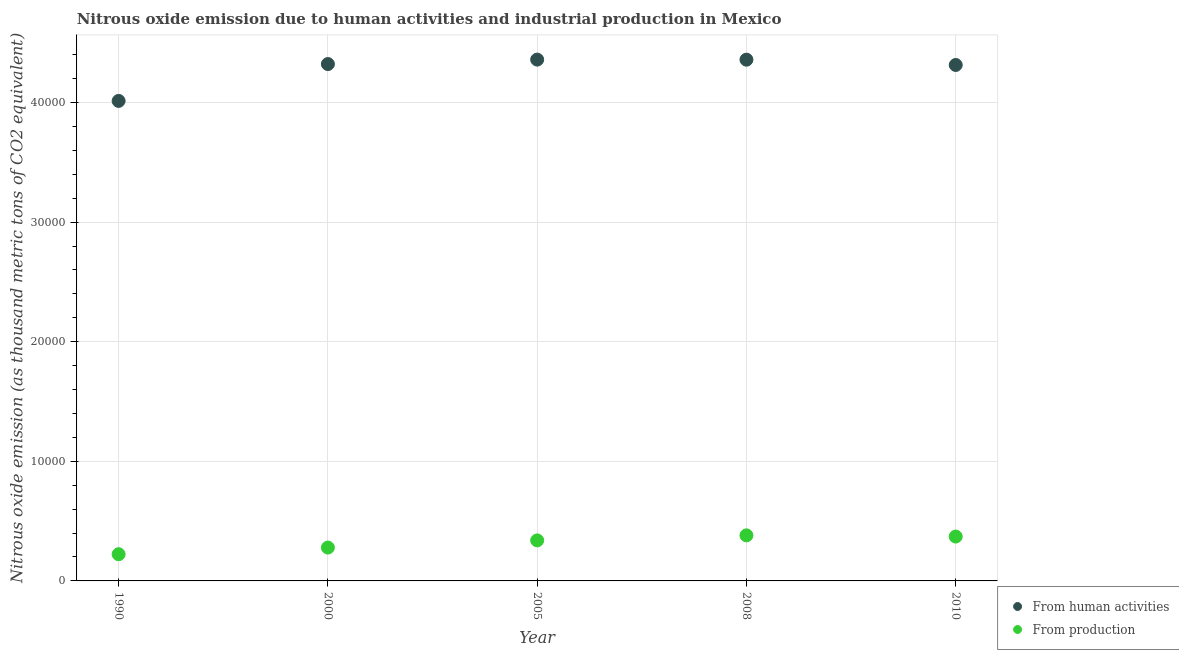What is the amount of emissions generated from industries in 2005?
Give a very brief answer. 3387.8. Across all years, what is the maximum amount of emissions from human activities?
Your answer should be very brief. 4.36e+04. Across all years, what is the minimum amount of emissions from human activities?
Offer a terse response. 4.01e+04. In which year was the amount of emissions generated from industries maximum?
Provide a succinct answer. 2008. What is the total amount of emissions from human activities in the graph?
Offer a very short reply. 2.14e+05. What is the difference between the amount of emissions from human activities in 2000 and that in 2010?
Offer a very short reply. 76.4. What is the difference between the amount of emissions from human activities in 2000 and the amount of emissions generated from industries in 2005?
Make the answer very short. 3.98e+04. What is the average amount of emissions from human activities per year?
Give a very brief answer. 4.27e+04. In the year 2000, what is the difference between the amount of emissions from human activities and amount of emissions generated from industries?
Ensure brevity in your answer.  4.04e+04. What is the ratio of the amount of emissions from human activities in 2000 to that in 2008?
Keep it short and to the point. 0.99. Is the amount of emissions from human activities in 2000 less than that in 2005?
Provide a succinct answer. Yes. Is the difference between the amount of emissions generated from industries in 2005 and 2008 greater than the difference between the amount of emissions from human activities in 2005 and 2008?
Offer a terse response. No. What is the difference between the highest and the second highest amount of emissions generated from industries?
Make the answer very short. 99.5. What is the difference between the highest and the lowest amount of emissions from human activities?
Your answer should be very brief. 3453. In how many years, is the amount of emissions generated from industries greater than the average amount of emissions generated from industries taken over all years?
Make the answer very short. 3. Is the sum of the amount of emissions from human activities in 1990 and 2010 greater than the maximum amount of emissions generated from industries across all years?
Offer a terse response. Yes. Does the amount of emissions from human activities monotonically increase over the years?
Keep it short and to the point. No. Is the amount of emissions from human activities strictly less than the amount of emissions generated from industries over the years?
Offer a terse response. No. Are the values on the major ticks of Y-axis written in scientific E-notation?
Offer a terse response. No. Does the graph contain grids?
Provide a succinct answer. Yes. Where does the legend appear in the graph?
Provide a succinct answer. Bottom right. How are the legend labels stacked?
Ensure brevity in your answer.  Vertical. What is the title of the graph?
Provide a short and direct response. Nitrous oxide emission due to human activities and industrial production in Mexico. What is the label or title of the X-axis?
Your response must be concise. Year. What is the label or title of the Y-axis?
Ensure brevity in your answer.  Nitrous oxide emission (as thousand metric tons of CO2 equivalent). What is the Nitrous oxide emission (as thousand metric tons of CO2 equivalent) of From human activities in 1990?
Keep it short and to the point. 4.01e+04. What is the Nitrous oxide emission (as thousand metric tons of CO2 equivalent) in From production in 1990?
Make the answer very short. 2233.4. What is the Nitrous oxide emission (as thousand metric tons of CO2 equivalent) in From human activities in 2000?
Offer a terse response. 4.32e+04. What is the Nitrous oxide emission (as thousand metric tons of CO2 equivalent) of From production in 2000?
Provide a short and direct response. 2789.1. What is the Nitrous oxide emission (as thousand metric tons of CO2 equivalent) in From human activities in 2005?
Give a very brief answer. 4.36e+04. What is the Nitrous oxide emission (as thousand metric tons of CO2 equivalent) in From production in 2005?
Your response must be concise. 3387.8. What is the Nitrous oxide emission (as thousand metric tons of CO2 equivalent) of From human activities in 2008?
Your response must be concise. 4.36e+04. What is the Nitrous oxide emission (as thousand metric tons of CO2 equivalent) in From production in 2008?
Offer a terse response. 3808.7. What is the Nitrous oxide emission (as thousand metric tons of CO2 equivalent) of From human activities in 2010?
Provide a short and direct response. 4.31e+04. What is the Nitrous oxide emission (as thousand metric tons of CO2 equivalent) in From production in 2010?
Your answer should be compact. 3709.2. Across all years, what is the maximum Nitrous oxide emission (as thousand metric tons of CO2 equivalent) in From human activities?
Make the answer very short. 4.36e+04. Across all years, what is the maximum Nitrous oxide emission (as thousand metric tons of CO2 equivalent) of From production?
Give a very brief answer. 3808.7. Across all years, what is the minimum Nitrous oxide emission (as thousand metric tons of CO2 equivalent) in From human activities?
Give a very brief answer. 4.01e+04. Across all years, what is the minimum Nitrous oxide emission (as thousand metric tons of CO2 equivalent) of From production?
Give a very brief answer. 2233.4. What is the total Nitrous oxide emission (as thousand metric tons of CO2 equivalent) of From human activities in the graph?
Your response must be concise. 2.14e+05. What is the total Nitrous oxide emission (as thousand metric tons of CO2 equivalent) in From production in the graph?
Your answer should be compact. 1.59e+04. What is the difference between the Nitrous oxide emission (as thousand metric tons of CO2 equivalent) of From human activities in 1990 and that in 2000?
Your answer should be very brief. -3080.7. What is the difference between the Nitrous oxide emission (as thousand metric tons of CO2 equivalent) of From production in 1990 and that in 2000?
Your answer should be compact. -555.7. What is the difference between the Nitrous oxide emission (as thousand metric tons of CO2 equivalent) of From human activities in 1990 and that in 2005?
Keep it short and to the point. -3453. What is the difference between the Nitrous oxide emission (as thousand metric tons of CO2 equivalent) of From production in 1990 and that in 2005?
Provide a short and direct response. -1154.4. What is the difference between the Nitrous oxide emission (as thousand metric tons of CO2 equivalent) of From human activities in 1990 and that in 2008?
Give a very brief answer. -3446.9. What is the difference between the Nitrous oxide emission (as thousand metric tons of CO2 equivalent) of From production in 1990 and that in 2008?
Your answer should be very brief. -1575.3. What is the difference between the Nitrous oxide emission (as thousand metric tons of CO2 equivalent) in From human activities in 1990 and that in 2010?
Provide a short and direct response. -3004.3. What is the difference between the Nitrous oxide emission (as thousand metric tons of CO2 equivalent) in From production in 1990 and that in 2010?
Keep it short and to the point. -1475.8. What is the difference between the Nitrous oxide emission (as thousand metric tons of CO2 equivalent) in From human activities in 2000 and that in 2005?
Offer a terse response. -372.3. What is the difference between the Nitrous oxide emission (as thousand metric tons of CO2 equivalent) in From production in 2000 and that in 2005?
Keep it short and to the point. -598.7. What is the difference between the Nitrous oxide emission (as thousand metric tons of CO2 equivalent) in From human activities in 2000 and that in 2008?
Give a very brief answer. -366.2. What is the difference between the Nitrous oxide emission (as thousand metric tons of CO2 equivalent) in From production in 2000 and that in 2008?
Ensure brevity in your answer.  -1019.6. What is the difference between the Nitrous oxide emission (as thousand metric tons of CO2 equivalent) in From human activities in 2000 and that in 2010?
Make the answer very short. 76.4. What is the difference between the Nitrous oxide emission (as thousand metric tons of CO2 equivalent) of From production in 2000 and that in 2010?
Offer a terse response. -920.1. What is the difference between the Nitrous oxide emission (as thousand metric tons of CO2 equivalent) of From human activities in 2005 and that in 2008?
Your response must be concise. 6.1. What is the difference between the Nitrous oxide emission (as thousand metric tons of CO2 equivalent) in From production in 2005 and that in 2008?
Keep it short and to the point. -420.9. What is the difference between the Nitrous oxide emission (as thousand metric tons of CO2 equivalent) of From human activities in 2005 and that in 2010?
Offer a terse response. 448.7. What is the difference between the Nitrous oxide emission (as thousand metric tons of CO2 equivalent) in From production in 2005 and that in 2010?
Make the answer very short. -321.4. What is the difference between the Nitrous oxide emission (as thousand metric tons of CO2 equivalent) of From human activities in 2008 and that in 2010?
Your answer should be very brief. 442.6. What is the difference between the Nitrous oxide emission (as thousand metric tons of CO2 equivalent) in From production in 2008 and that in 2010?
Offer a terse response. 99.5. What is the difference between the Nitrous oxide emission (as thousand metric tons of CO2 equivalent) of From human activities in 1990 and the Nitrous oxide emission (as thousand metric tons of CO2 equivalent) of From production in 2000?
Your answer should be very brief. 3.73e+04. What is the difference between the Nitrous oxide emission (as thousand metric tons of CO2 equivalent) in From human activities in 1990 and the Nitrous oxide emission (as thousand metric tons of CO2 equivalent) in From production in 2005?
Keep it short and to the point. 3.67e+04. What is the difference between the Nitrous oxide emission (as thousand metric tons of CO2 equivalent) of From human activities in 1990 and the Nitrous oxide emission (as thousand metric tons of CO2 equivalent) of From production in 2008?
Give a very brief answer. 3.63e+04. What is the difference between the Nitrous oxide emission (as thousand metric tons of CO2 equivalent) of From human activities in 1990 and the Nitrous oxide emission (as thousand metric tons of CO2 equivalent) of From production in 2010?
Ensure brevity in your answer.  3.64e+04. What is the difference between the Nitrous oxide emission (as thousand metric tons of CO2 equivalent) in From human activities in 2000 and the Nitrous oxide emission (as thousand metric tons of CO2 equivalent) in From production in 2005?
Ensure brevity in your answer.  3.98e+04. What is the difference between the Nitrous oxide emission (as thousand metric tons of CO2 equivalent) in From human activities in 2000 and the Nitrous oxide emission (as thousand metric tons of CO2 equivalent) in From production in 2008?
Offer a terse response. 3.94e+04. What is the difference between the Nitrous oxide emission (as thousand metric tons of CO2 equivalent) in From human activities in 2000 and the Nitrous oxide emission (as thousand metric tons of CO2 equivalent) in From production in 2010?
Provide a succinct answer. 3.95e+04. What is the difference between the Nitrous oxide emission (as thousand metric tons of CO2 equivalent) in From human activities in 2005 and the Nitrous oxide emission (as thousand metric tons of CO2 equivalent) in From production in 2008?
Offer a terse response. 3.98e+04. What is the difference between the Nitrous oxide emission (as thousand metric tons of CO2 equivalent) of From human activities in 2005 and the Nitrous oxide emission (as thousand metric tons of CO2 equivalent) of From production in 2010?
Your response must be concise. 3.99e+04. What is the difference between the Nitrous oxide emission (as thousand metric tons of CO2 equivalent) in From human activities in 2008 and the Nitrous oxide emission (as thousand metric tons of CO2 equivalent) in From production in 2010?
Provide a succinct answer. 3.99e+04. What is the average Nitrous oxide emission (as thousand metric tons of CO2 equivalent) in From human activities per year?
Give a very brief answer. 4.27e+04. What is the average Nitrous oxide emission (as thousand metric tons of CO2 equivalent) in From production per year?
Your answer should be very brief. 3185.64. In the year 1990, what is the difference between the Nitrous oxide emission (as thousand metric tons of CO2 equivalent) in From human activities and Nitrous oxide emission (as thousand metric tons of CO2 equivalent) in From production?
Give a very brief answer. 3.79e+04. In the year 2000, what is the difference between the Nitrous oxide emission (as thousand metric tons of CO2 equivalent) in From human activities and Nitrous oxide emission (as thousand metric tons of CO2 equivalent) in From production?
Provide a succinct answer. 4.04e+04. In the year 2005, what is the difference between the Nitrous oxide emission (as thousand metric tons of CO2 equivalent) of From human activities and Nitrous oxide emission (as thousand metric tons of CO2 equivalent) of From production?
Make the answer very short. 4.02e+04. In the year 2008, what is the difference between the Nitrous oxide emission (as thousand metric tons of CO2 equivalent) of From human activities and Nitrous oxide emission (as thousand metric tons of CO2 equivalent) of From production?
Give a very brief answer. 3.98e+04. In the year 2010, what is the difference between the Nitrous oxide emission (as thousand metric tons of CO2 equivalent) of From human activities and Nitrous oxide emission (as thousand metric tons of CO2 equivalent) of From production?
Your response must be concise. 3.94e+04. What is the ratio of the Nitrous oxide emission (as thousand metric tons of CO2 equivalent) of From human activities in 1990 to that in 2000?
Keep it short and to the point. 0.93. What is the ratio of the Nitrous oxide emission (as thousand metric tons of CO2 equivalent) in From production in 1990 to that in 2000?
Offer a terse response. 0.8. What is the ratio of the Nitrous oxide emission (as thousand metric tons of CO2 equivalent) in From human activities in 1990 to that in 2005?
Keep it short and to the point. 0.92. What is the ratio of the Nitrous oxide emission (as thousand metric tons of CO2 equivalent) in From production in 1990 to that in 2005?
Make the answer very short. 0.66. What is the ratio of the Nitrous oxide emission (as thousand metric tons of CO2 equivalent) in From human activities in 1990 to that in 2008?
Keep it short and to the point. 0.92. What is the ratio of the Nitrous oxide emission (as thousand metric tons of CO2 equivalent) in From production in 1990 to that in 2008?
Offer a very short reply. 0.59. What is the ratio of the Nitrous oxide emission (as thousand metric tons of CO2 equivalent) in From human activities in 1990 to that in 2010?
Your response must be concise. 0.93. What is the ratio of the Nitrous oxide emission (as thousand metric tons of CO2 equivalent) of From production in 1990 to that in 2010?
Give a very brief answer. 0.6. What is the ratio of the Nitrous oxide emission (as thousand metric tons of CO2 equivalent) of From human activities in 2000 to that in 2005?
Keep it short and to the point. 0.99. What is the ratio of the Nitrous oxide emission (as thousand metric tons of CO2 equivalent) in From production in 2000 to that in 2005?
Your answer should be very brief. 0.82. What is the ratio of the Nitrous oxide emission (as thousand metric tons of CO2 equivalent) in From human activities in 2000 to that in 2008?
Offer a terse response. 0.99. What is the ratio of the Nitrous oxide emission (as thousand metric tons of CO2 equivalent) of From production in 2000 to that in 2008?
Ensure brevity in your answer.  0.73. What is the ratio of the Nitrous oxide emission (as thousand metric tons of CO2 equivalent) in From human activities in 2000 to that in 2010?
Your response must be concise. 1. What is the ratio of the Nitrous oxide emission (as thousand metric tons of CO2 equivalent) in From production in 2000 to that in 2010?
Offer a very short reply. 0.75. What is the ratio of the Nitrous oxide emission (as thousand metric tons of CO2 equivalent) of From production in 2005 to that in 2008?
Your response must be concise. 0.89. What is the ratio of the Nitrous oxide emission (as thousand metric tons of CO2 equivalent) in From human activities in 2005 to that in 2010?
Your answer should be very brief. 1.01. What is the ratio of the Nitrous oxide emission (as thousand metric tons of CO2 equivalent) of From production in 2005 to that in 2010?
Ensure brevity in your answer.  0.91. What is the ratio of the Nitrous oxide emission (as thousand metric tons of CO2 equivalent) in From human activities in 2008 to that in 2010?
Offer a terse response. 1.01. What is the ratio of the Nitrous oxide emission (as thousand metric tons of CO2 equivalent) in From production in 2008 to that in 2010?
Ensure brevity in your answer.  1.03. What is the difference between the highest and the second highest Nitrous oxide emission (as thousand metric tons of CO2 equivalent) in From production?
Your answer should be compact. 99.5. What is the difference between the highest and the lowest Nitrous oxide emission (as thousand metric tons of CO2 equivalent) in From human activities?
Make the answer very short. 3453. What is the difference between the highest and the lowest Nitrous oxide emission (as thousand metric tons of CO2 equivalent) of From production?
Ensure brevity in your answer.  1575.3. 